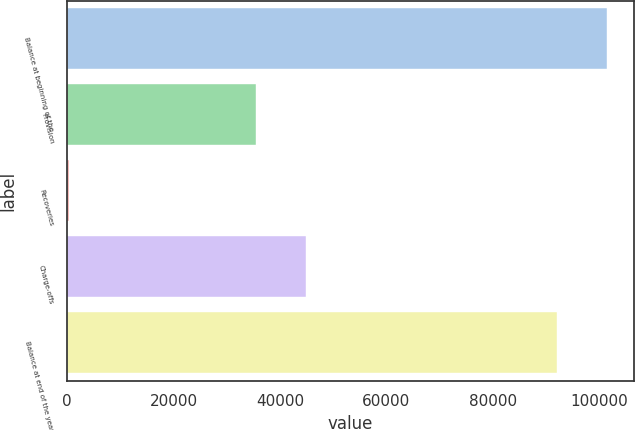Convert chart to OTSL. <chart><loc_0><loc_0><loc_500><loc_500><bar_chart><fcel>Balance at beginning of the<fcel>Provision<fcel>Recoveries<fcel>Charge-offs<fcel>Balance at end of the year<nl><fcel>101413<fcel>35567<fcel>272<fcel>44893.3<fcel>92087<nl></chart> 